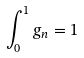Convert formula to latex. <formula><loc_0><loc_0><loc_500><loc_500>\int _ { 0 } ^ { 1 } g _ { n } = 1</formula> 